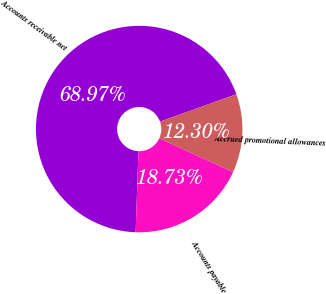Convert chart. <chart><loc_0><loc_0><loc_500><loc_500><pie_chart><fcel>Accounts receivable net<fcel>Accounts payable<fcel>Accrued promotional allowances<nl><fcel>68.97%<fcel>18.73%<fcel>12.3%<nl></chart> 